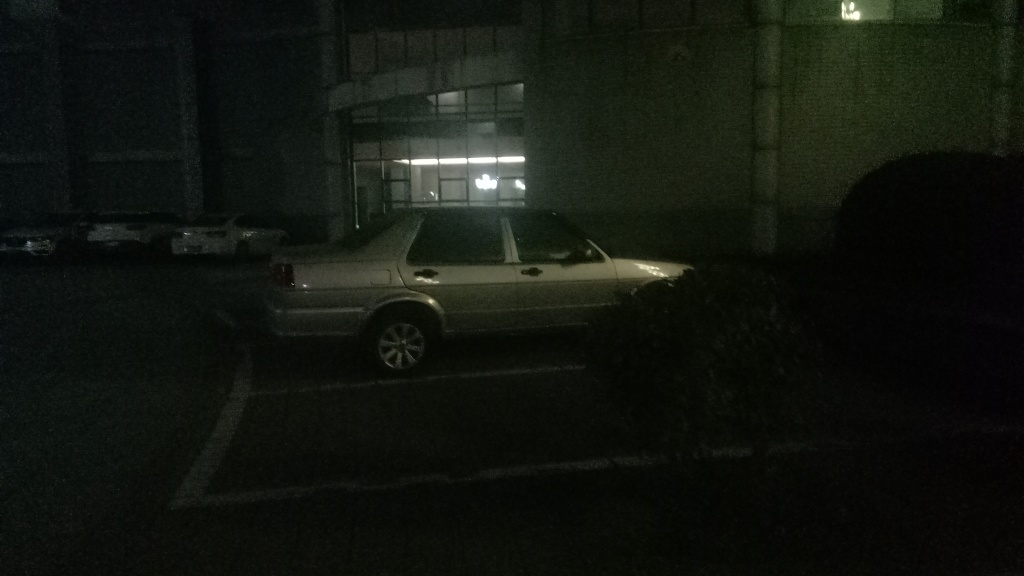What is the quality of this image?
A. Excellent
B. Good
C. Average
D. Very poor
Answer with the option's letter from the given choices directly. The quality of the image is quite poor, which corresponds to option D. Very Poor. The image is underexposed, making it difficult to see details clearly. The lighting is inadequate, and as a result, the contents are not easily discernible. For better image quality, it would require adequate lighting and perhaps a higher resolution to capture more detail. 